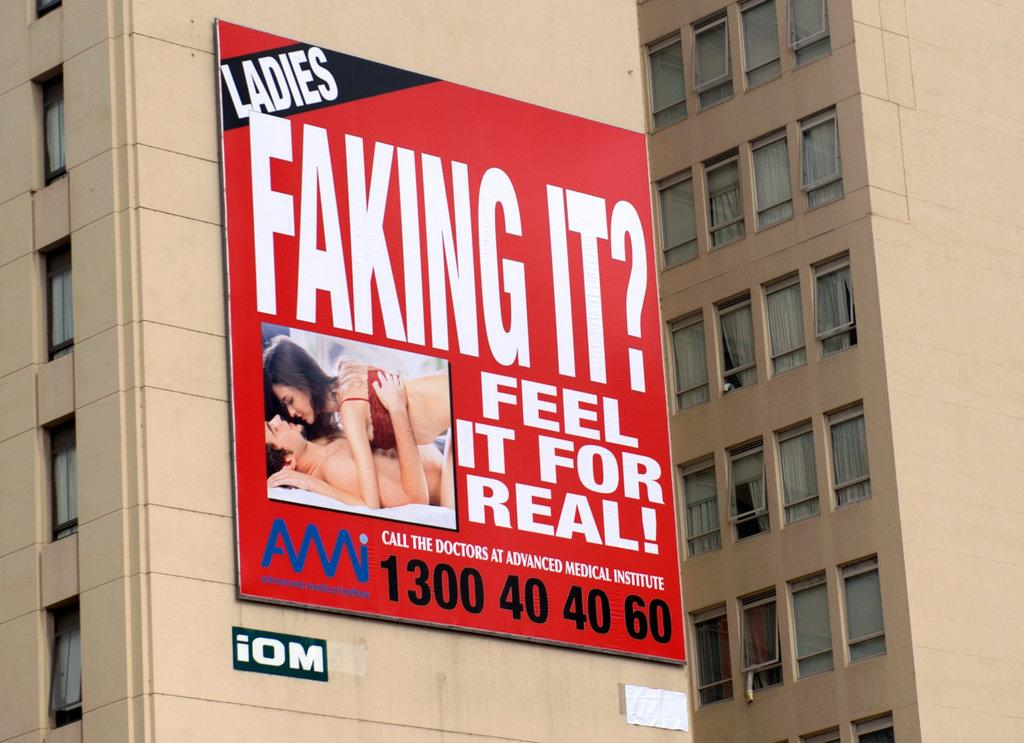What is displayed on the walls of the building in the image? There is an advertisement on the walls of a building in the image. What type of liquid can be seen flowing from the top of the building in the image? There is no liquid flowing from the top of the building in the image; it only features an advertisement on the walls. 